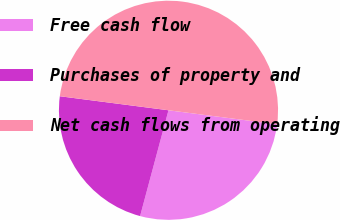Convert chart to OTSL. <chart><loc_0><loc_0><loc_500><loc_500><pie_chart><fcel>Free cash flow<fcel>Purchases of property and<fcel>Net cash flows from operating<nl><fcel>27.13%<fcel>22.87%<fcel>50.0%<nl></chart> 